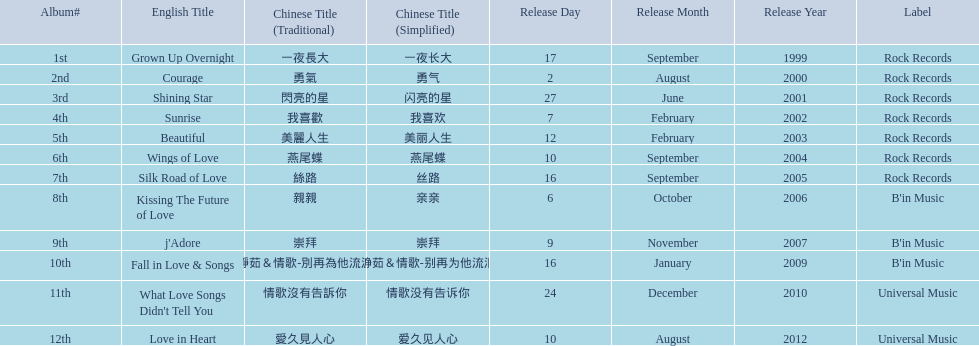Which english titles were released during even years? Courage, Sunrise, Silk Road of Love, Kissing The Future of Love, What Love Songs Didn't Tell You, Love in Heart. Out of the following, which one was released under b's in music? Kissing The Future of Love. 